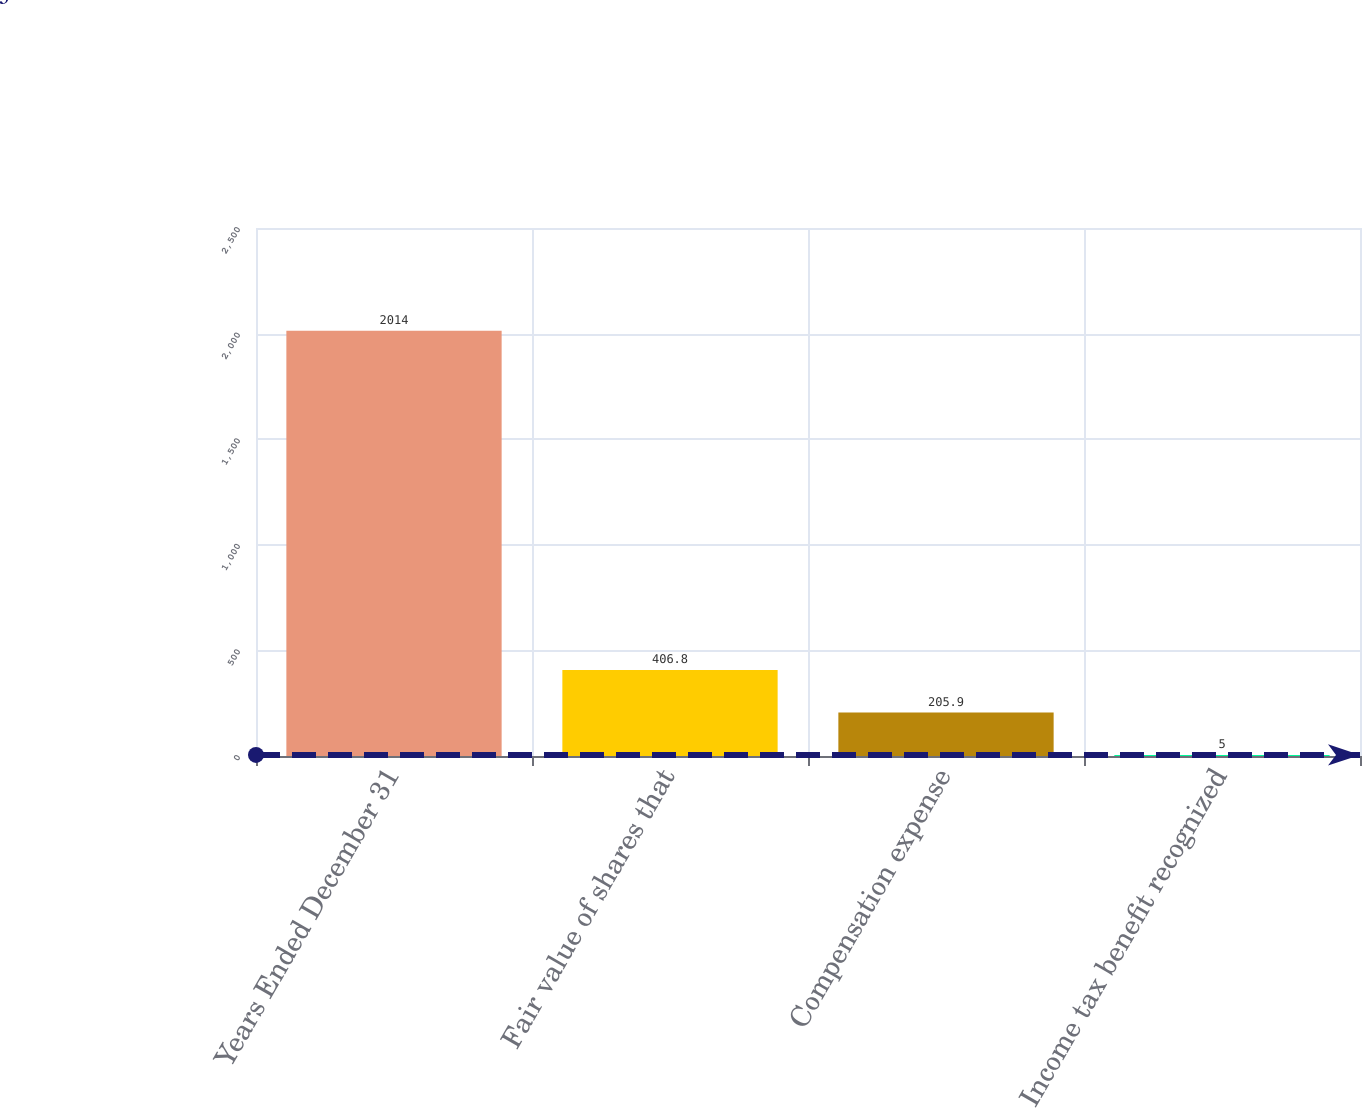Convert chart to OTSL. <chart><loc_0><loc_0><loc_500><loc_500><bar_chart><fcel>Years Ended December 31<fcel>Fair value of shares that<fcel>Compensation expense<fcel>Income tax benefit recognized<nl><fcel>2014<fcel>406.8<fcel>205.9<fcel>5<nl></chart> 